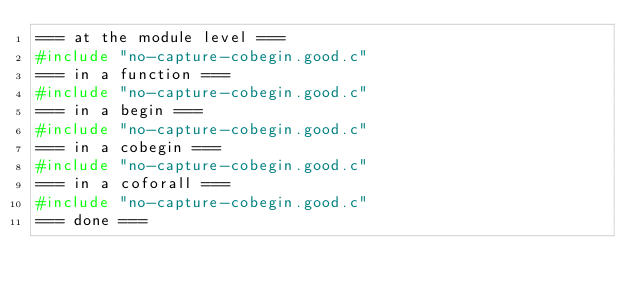<code> <loc_0><loc_0><loc_500><loc_500><_C_>=== at the module level ===
#include "no-capture-cobegin.good.c"
=== in a function ===
#include "no-capture-cobegin.good.c"
=== in a begin ===
#include "no-capture-cobegin.good.c"
=== in a cobegin ===
#include "no-capture-cobegin.good.c"
=== in a coforall ===
#include "no-capture-cobegin.good.c"
=== done ===
</code> 